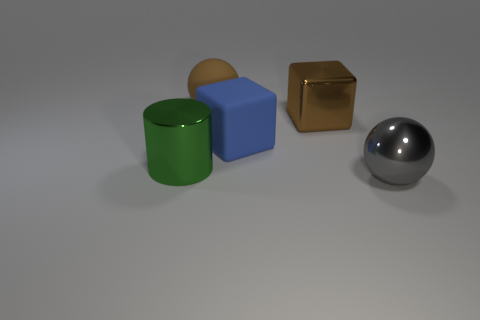What is the size of the other thing that is the same shape as the blue thing?
Provide a succinct answer. Large. What number of things are either metallic things that are in front of the large blue cube or big shiny things that are on the right side of the large metal cylinder?
Provide a succinct answer. 3. Is the number of green things less than the number of large matte things?
Make the answer very short. Yes. What number of shiny objects are either large cylinders or large blue objects?
Provide a short and direct response. 1. Is the number of green metallic objects greater than the number of brown objects?
Your answer should be very brief. No. What size is the rubber object that is the same color as the shiny block?
Ensure brevity in your answer.  Large. What shape is the big metal object behind the green cylinder that is left of the rubber sphere?
Your answer should be very brief. Cube. There is a big sphere behind the big ball to the right of the brown ball; are there any big metal objects on the right side of it?
Give a very brief answer. Yes. There is another cube that is the same size as the matte cube; what color is it?
Make the answer very short. Brown. What shape is the metallic thing that is both on the right side of the large cylinder and in front of the brown metallic cube?
Your answer should be very brief. Sphere. 